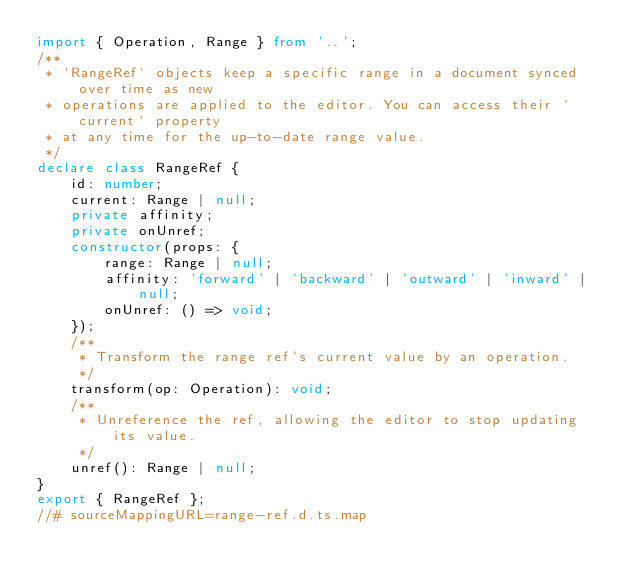Convert code to text. <code><loc_0><loc_0><loc_500><loc_500><_TypeScript_>import { Operation, Range } from '..';
/**
 * `RangeRef` objects keep a specific range in a document synced over time as new
 * operations are applied to the editor. You can access their `current` property
 * at any time for the up-to-date range value.
 */
declare class RangeRef {
    id: number;
    current: Range | null;
    private affinity;
    private onUnref;
    constructor(props: {
        range: Range | null;
        affinity: 'forward' | 'backward' | 'outward' | 'inward' | null;
        onUnref: () => void;
    });
    /**
     * Transform the range ref's current value by an operation.
     */
    transform(op: Operation): void;
    /**
     * Unreference the ref, allowing the editor to stop updating its value.
     */
    unref(): Range | null;
}
export { RangeRef };
//# sourceMappingURL=range-ref.d.ts.map</code> 